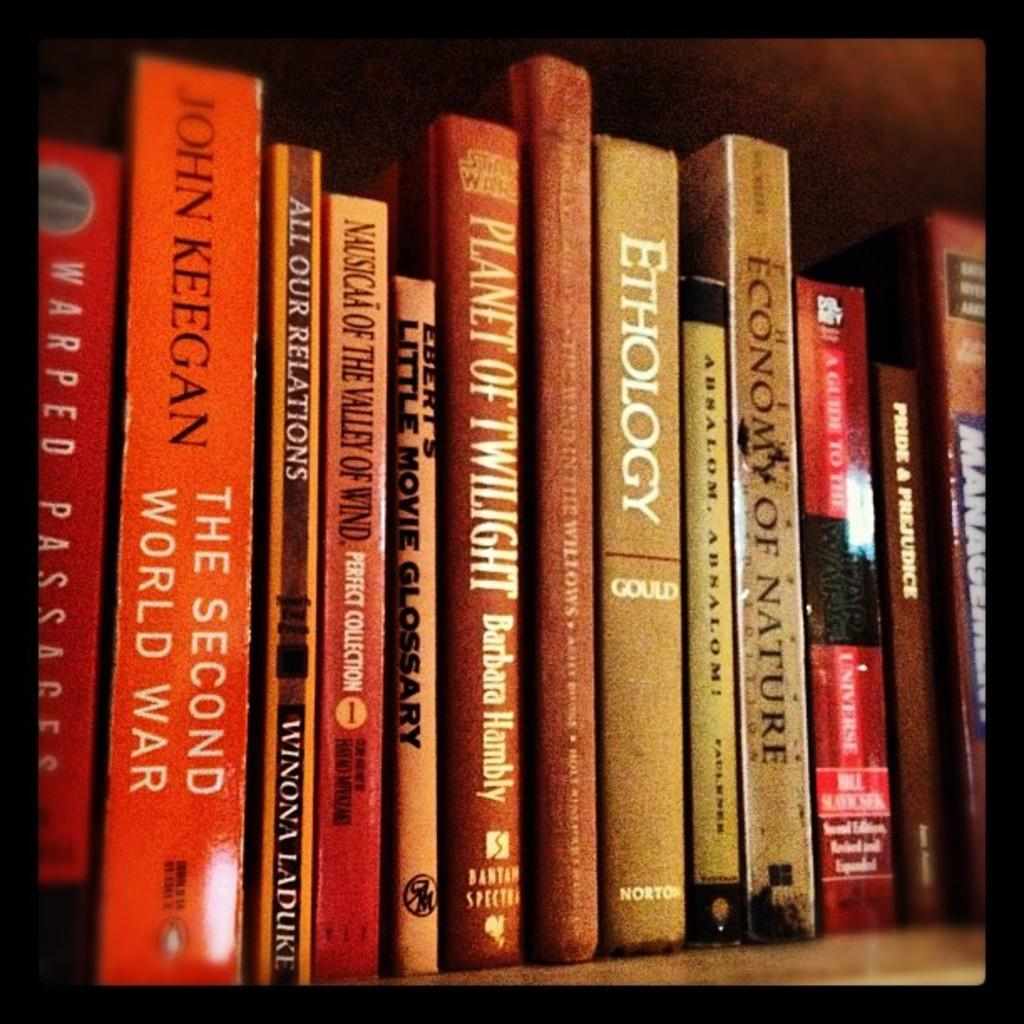<image>
Present a compact description of the photo's key features. Planet of Twilight by Barbara Hambly is printed onto the spine of this book. 